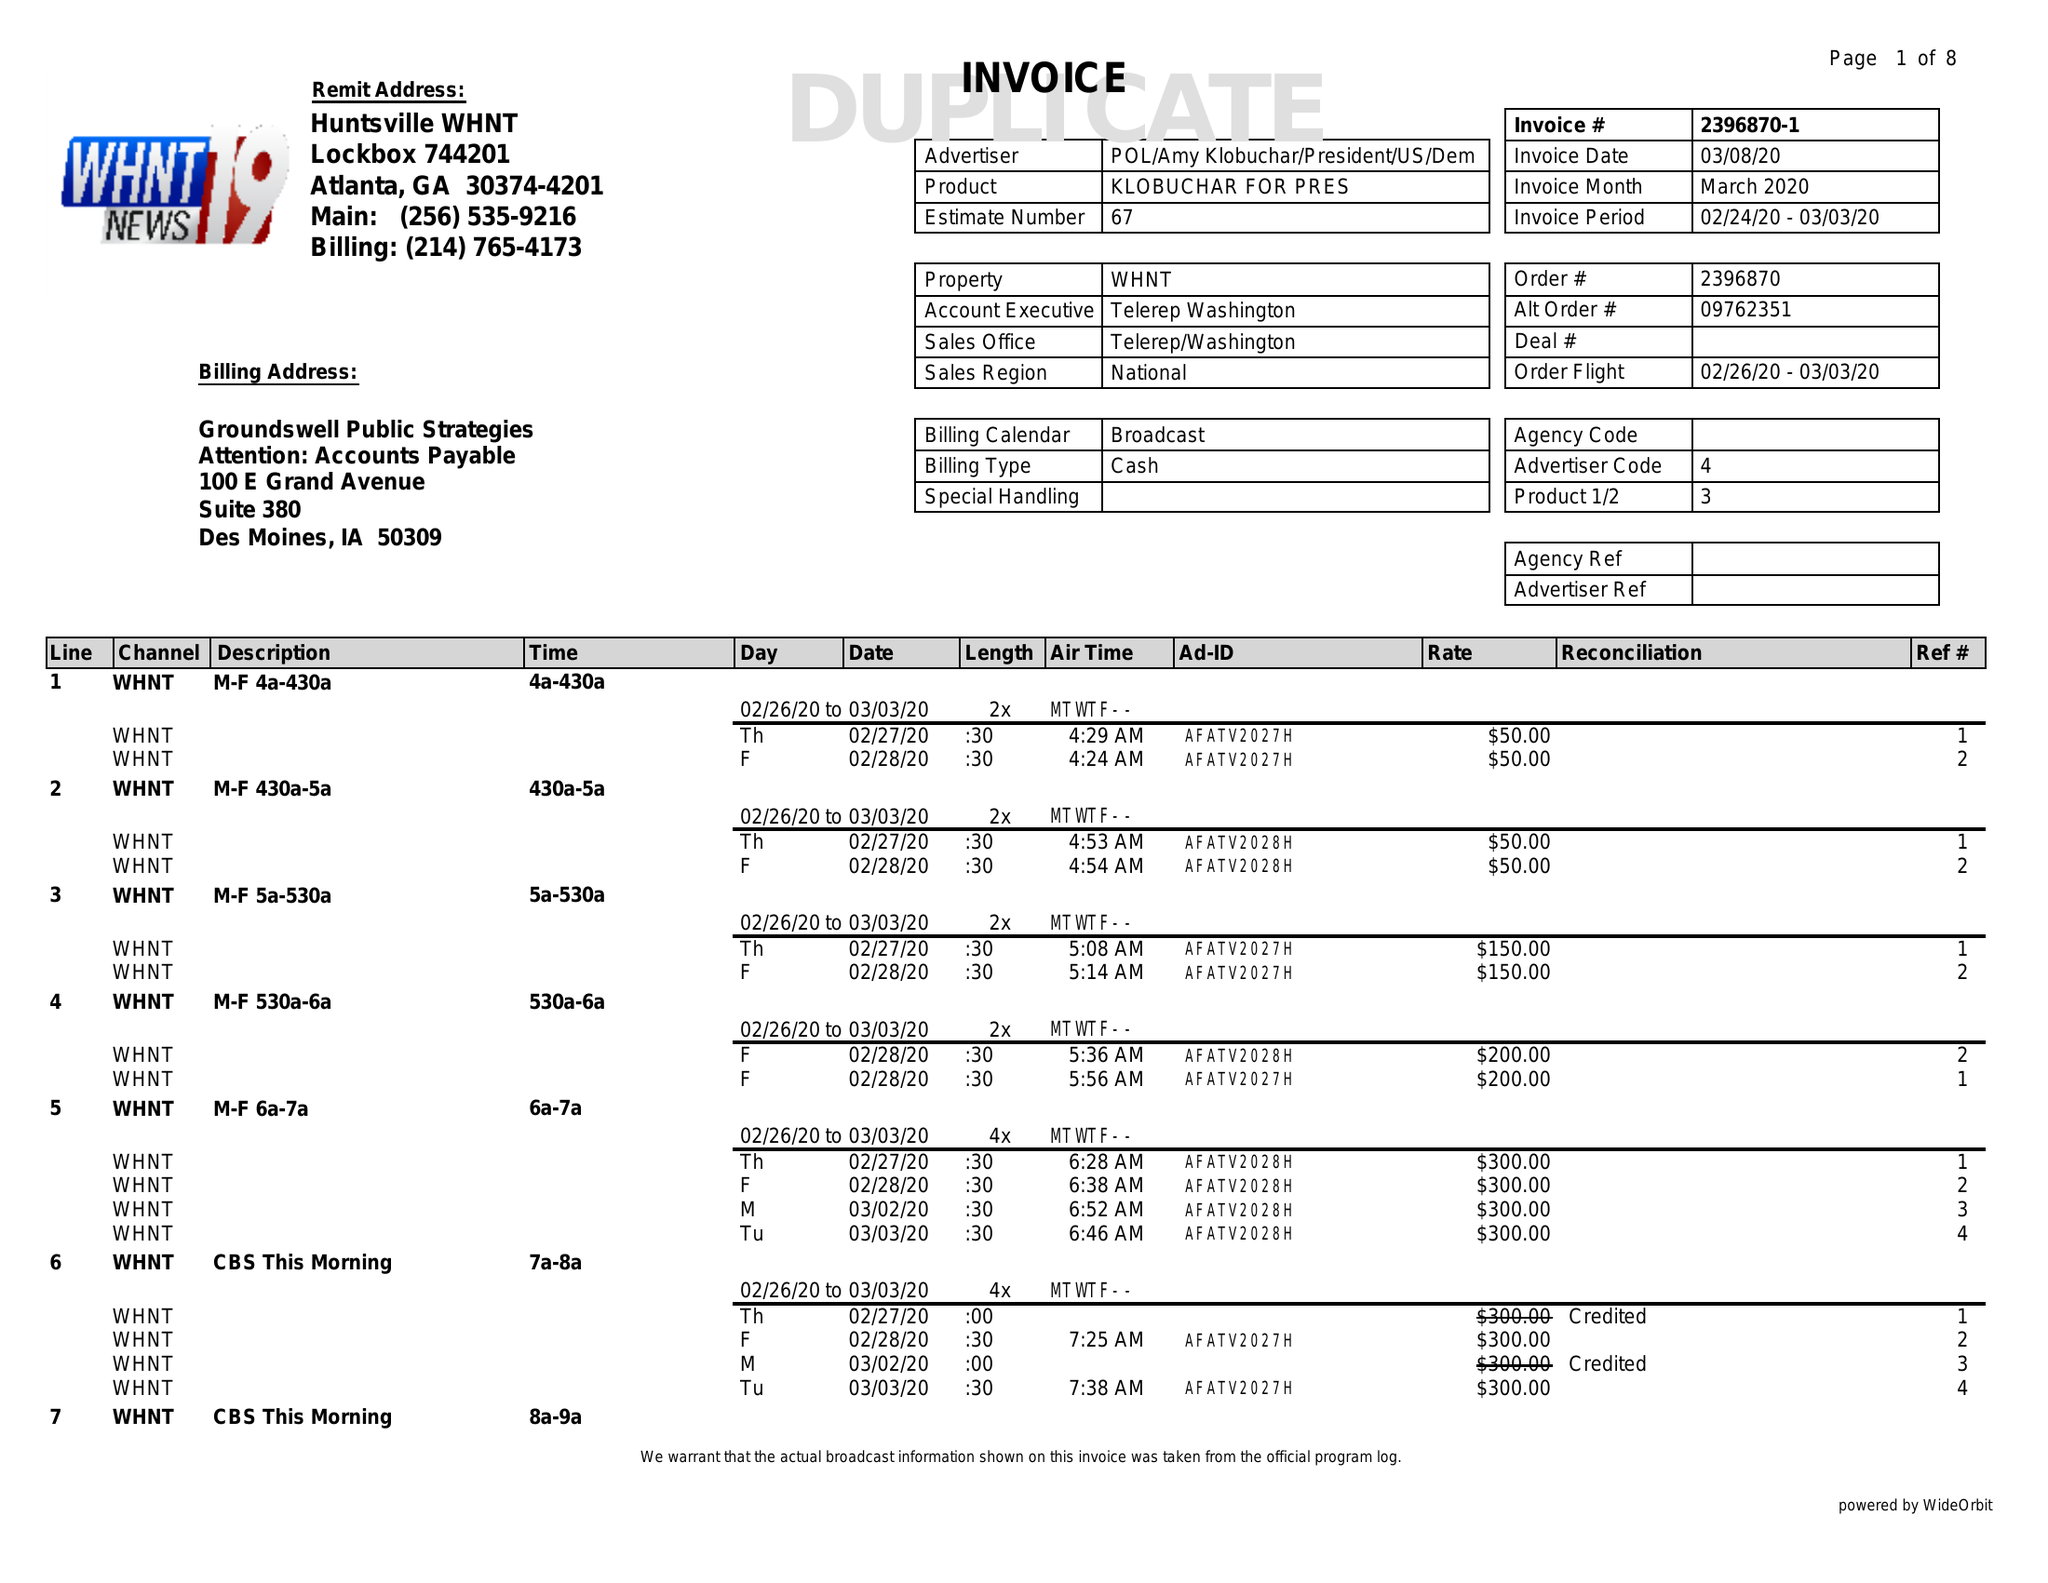What is the value for the gross_amount?
Answer the question using a single word or phrase. 36250.00 